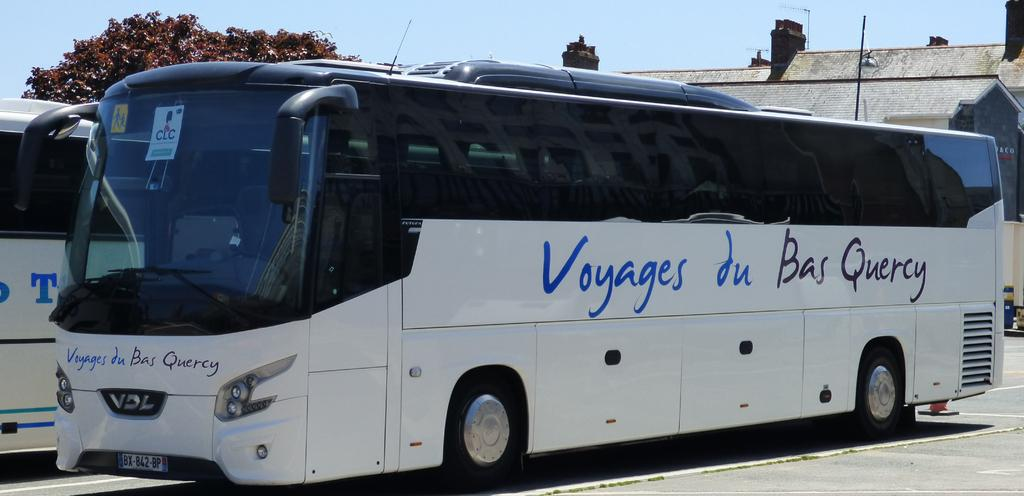What type of vehicles can be seen on the road in the image? There are motor vehicles on the road in the image. What structures are present in the image? There are buildings in the image. What type of vegetation is visible in the image? There are trees in the image. What part of the natural environment is visible in the image? The sky is visible in the image. What type of jam is being spread on the pet in the image? There is no jam or pet present in the image. What sound can be heard coming from the buildings in the image? The image is a still picture, so no sounds can be heard. 